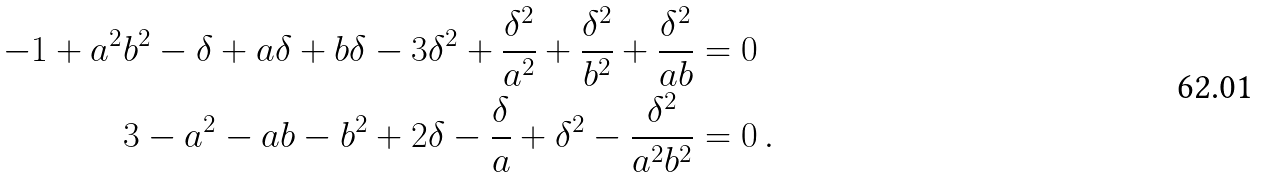Convert formula to latex. <formula><loc_0><loc_0><loc_500><loc_500>- 1 + a ^ { 2 } b ^ { 2 } - \delta + a \delta + b \delta - 3 \delta ^ { 2 } + \frac { \delta ^ { 2 } } { a ^ { 2 } } + \frac { \delta ^ { 2 } } { b ^ { 2 } } + \frac { \delta ^ { 2 } } { a b } & = 0 \\ 3 - a ^ { 2 } - a b - b ^ { 2 } + 2 \delta - \frac { \delta } { a } + \delta ^ { 2 } - \frac { \delta ^ { 2 } } { a ^ { 2 } b ^ { 2 } } & = 0 \, .</formula> 